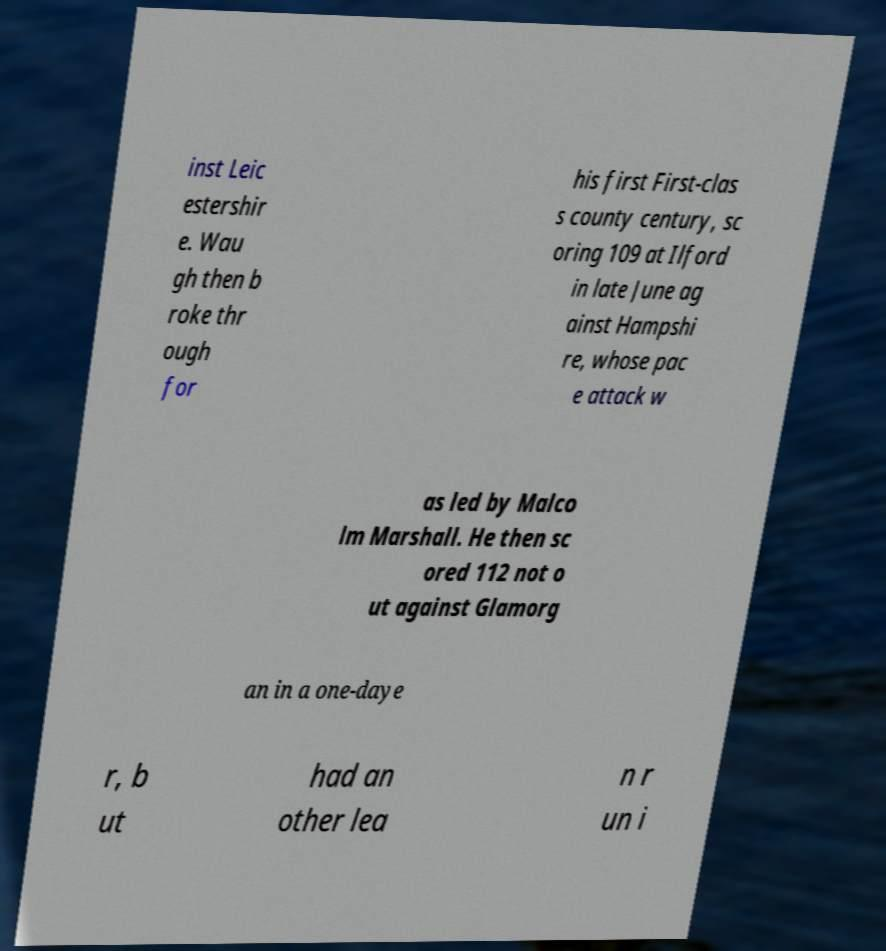Please read and relay the text visible in this image. What does it say? inst Leic estershir e. Wau gh then b roke thr ough for his first First-clas s county century, sc oring 109 at Ilford in late June ag ainst Hampshi re, whose pac e attack w as led by Malco lm Marshall. He then sc ored 112 not o ut against Glamorg an in a one-daye r, b ut had an other lea n r un i 